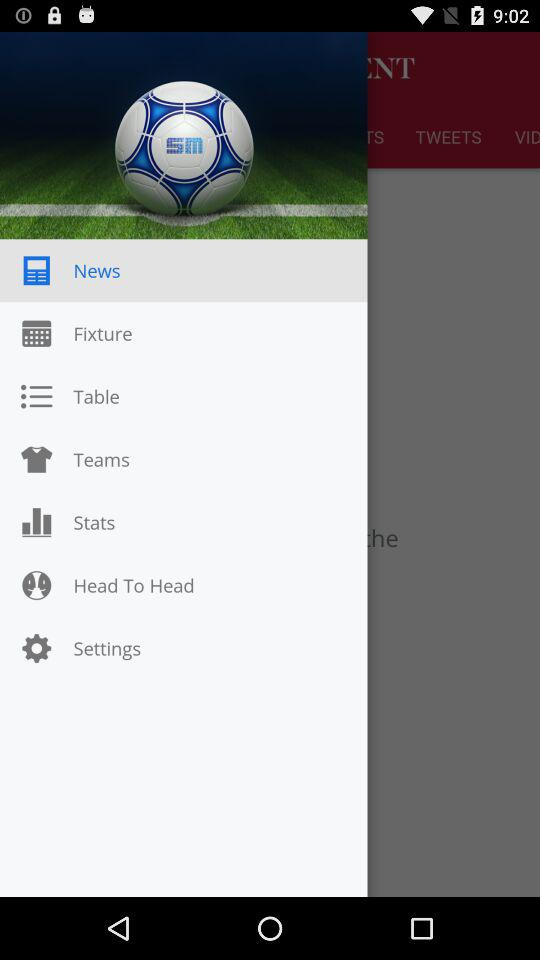Which option is selected? The selected option is News. 